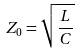<formula> <loc_0><loc_0><loc_500><loc_500>Z _ { 0 } = \sqrt { \frac { L } { C } }</formula> 